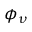Convert formula to latex. <formula><loc_0><loc_0><loc_500><loc_500>\phi _ { \nu }</formula> 